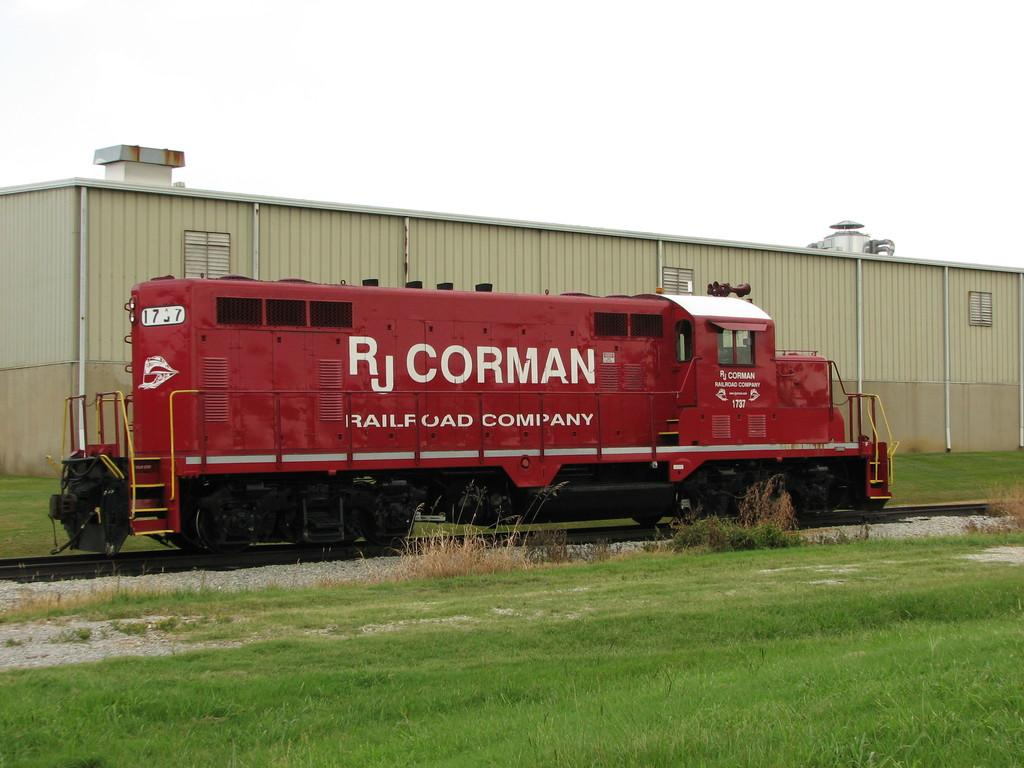<image>
Render a clear and concise summary of the photo. A red train car says "RJ CORMAN RAILROAD COMPANY" on the side. 